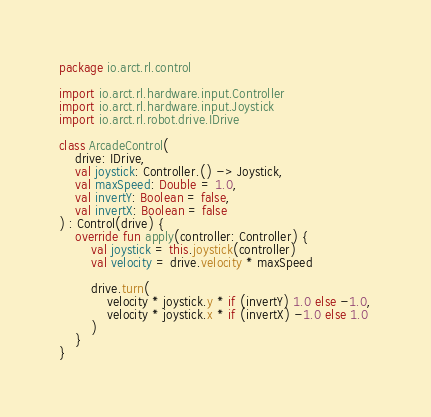<code> <loc_0><loc_0><loc_500><loc_500><_Kotlin_>package io.arct.rl.control

import io.arct.rl.hardware.input.Controller
import io.arct.rl.hardware.input.Joystick
import io.arct.rl.robot.drive.IDrive

class ArcadeControl(
    drive: IDrive,
    val joystick: Controller.() -> Joystick,
    val maxSpeed: Double = 1.0,
    val invertY: Boolean = false,
    val invertX: Boolean = false
) : Control(drive) {
    override fun apply(controller: Controller) {
        val joystick = this.joystick(controller)
        val velocity = drive.velocity * maxSpeed

        drive.turn(
            velocity * joystick.y * if (invertY) 1.0 else -1.0,
            velocity * joystick.x * if (invertX) -1.0 else 1.0
        )
    }
}</code> 